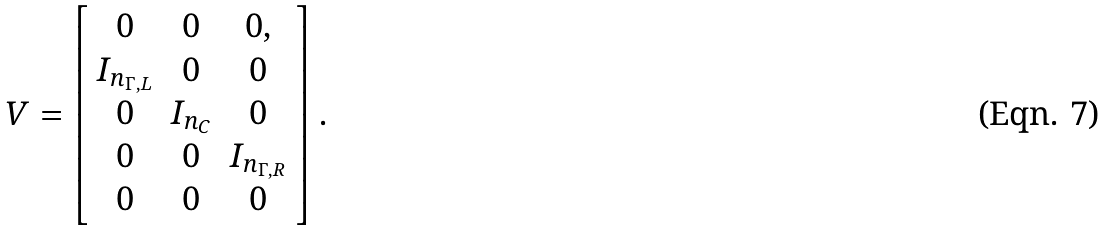Convert formula to latex. <formula><loc_0><loc_0><loc_500><loc_500>V = \left [ \begin{array} { c c c } 0 & 0 & 0 , \\ I _ { n _ { \Gamma , L } } & 0 & 0 \\ 0 & I _ { n _ { C } } & 0 \\ 0 & 0 & I _ { n _ { \Gamma , R } } \\ 0 & 0 & 0 \end{array} \right ] .</formula> 